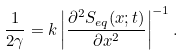<formula> <loc_0><loc_0><loc_500><loc_500>\frac { 1 } { 2 \gamma } = k \left | \frac { \partial ^ { 2 } S _ { e q } ( x ; t ) } { \partial x ^ { 2 } } \right | ^ { - 1 } .</formula> 